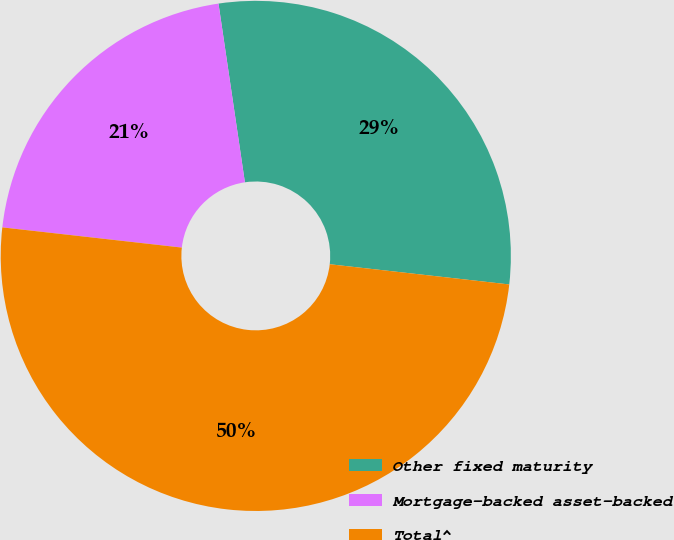<chart> <loc_0><loc_0><loc_500><loc_500><pie_chart><fcel>Other fixed maturity<fcel>Mortgage-backed asset-backed<fcel>Total^<nl><fcel>29.12%<fcel>20.88%<fcel>50.0%<nl></chart> 